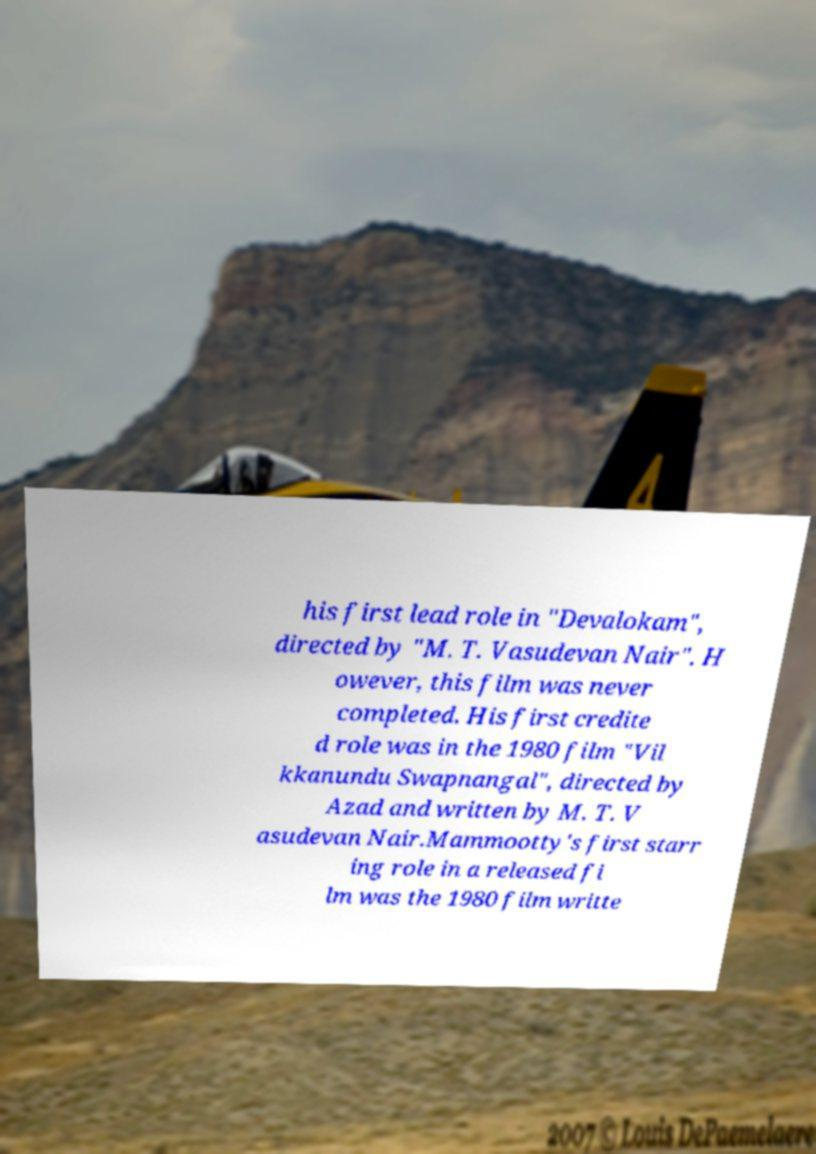There's text embedded in this image that I need extracted. Can you transcribe it verbatim? his first lead role in "Devalokam", directed by "M. T. Vasudevan Nair". H owever, this film was never completed. His first credite d role was in the 1980 film "Vil kkanundu Swapnangal", directed by Azad and written by M. T. V asudevan Nair.Mammootty's first starr ing role in a released fi lm was the 1980 film writte 